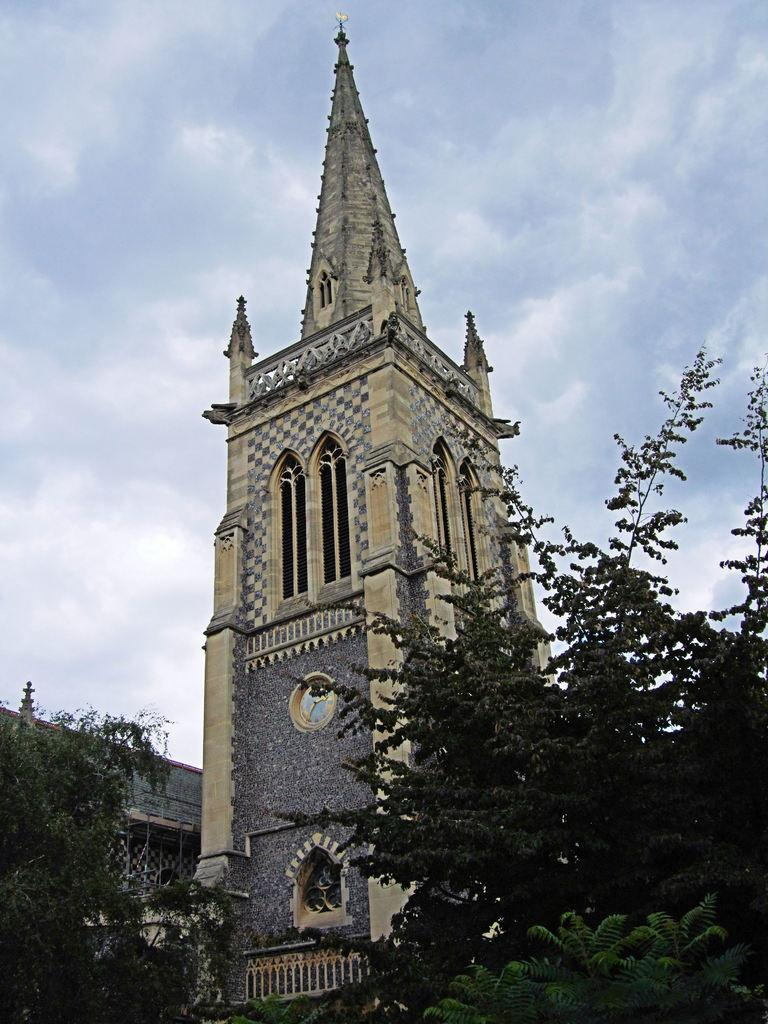What type of natural elements can be seen in the image? There are trees in the image. What type of man-made structures are present in the image? There are buildings in the image. What part of the natural environment is visible in the image? The sky is visible in the image. Reasoning: Let' Let's think step by step in order to produce the conversation. We start by identifying the main subjects in the image, which are the trees and buildings. Then, we expand the conversation to include the sky, which is also visible in the image. Each question is designed to elicit a specific detail about the image that is known from the provided facts. Absurd Question/Answer: What type of guitar can be seen on the shelf in the image? There is no guitar or shelf present in the image. How does the image suggest that the trees should be pushed? The image does not suggest that the trees should be pushed, as it is a static representation of the scene. What type of guitar can be seen on the shelf in the image? There is no guitar or shelf present in the image. How does the image suggest that the trees should be pushed? The image does not suggest that the trees should be pushed, as it is a static representation of the scene. 